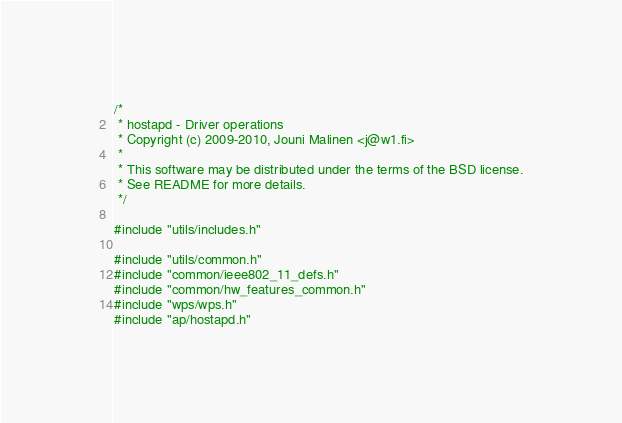<code> <loc_0><loc_0><loc_500><loc_500><_C_>/*
 * hostapd - Driver operations
 * Copyright (c) 2009-2010, Jouni Malinen <j@w1.fi>
 *
 * This software may be distributed under the terms of the BSD license.
 * See README for more details.
 */

#include "utils/includes.h"

#include "utils/common.h"
#include "common/ieee802_11_defs.h"
#include "common/hw_features_common.h"
#include "wps/wps.h"
#include "ap/hostapd.h"</code> 